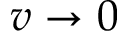<formula> <loc_0><loc_0><loc_500><loc_500>v \rightarrow 0</formula> 